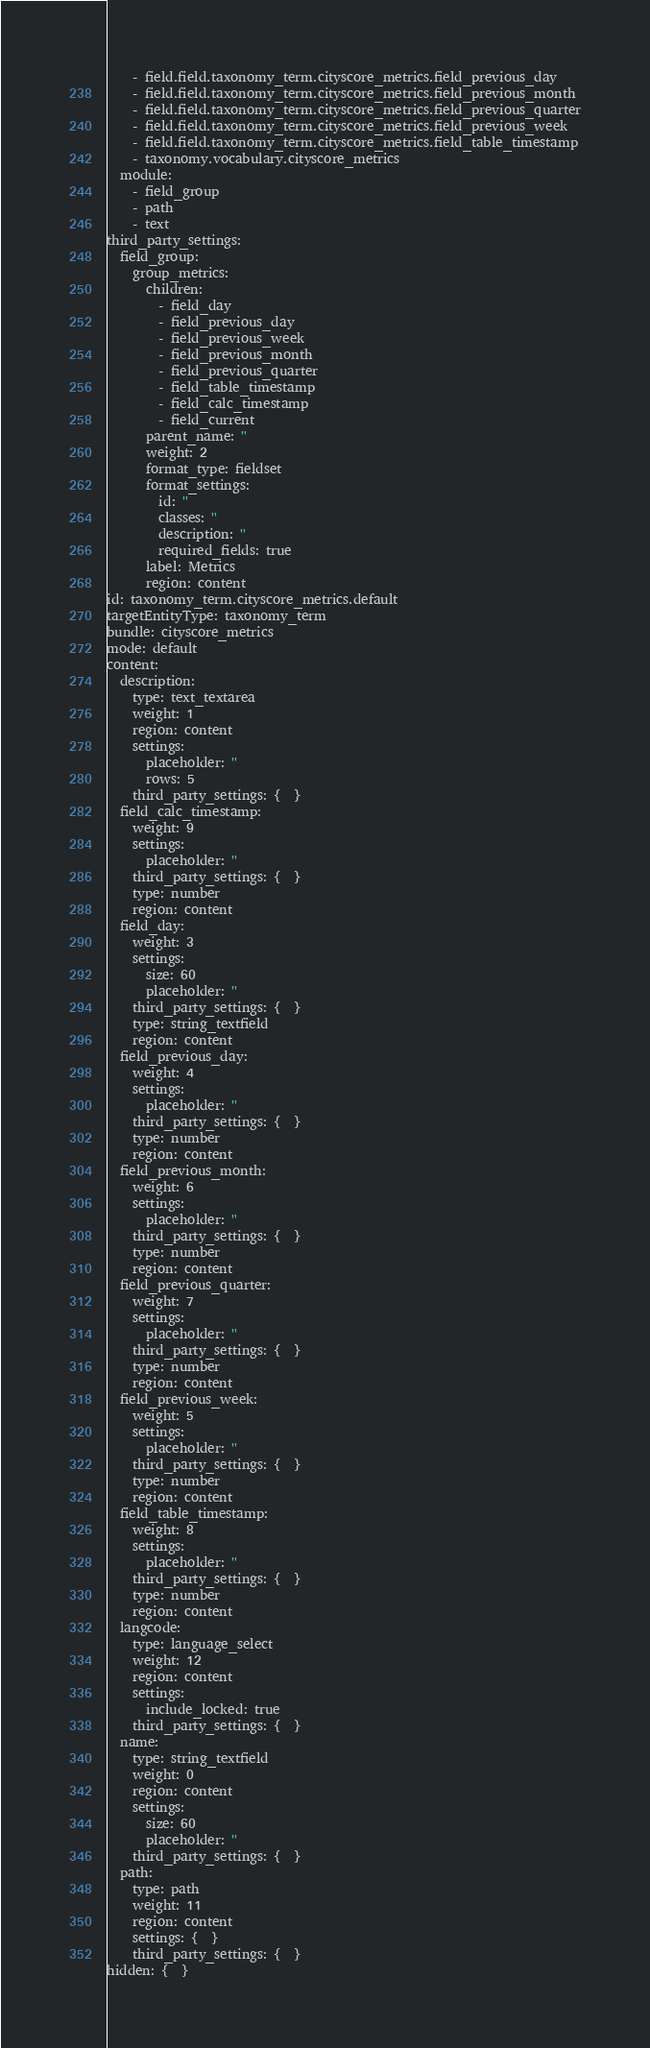Convert code to text. <code><loc_0><loc_0><loc_500><loc_500><_YAML_>    - field.field.taxonomy_term.cityscore_metrics.field_previous_day
    - field.field.taxonomy_term.cityscore_metrics.field_previous_month
    - field.field.taxonomy_term.cityscore_metrics.field_previous_quarter
    - field.field.taxonomy_term.cityscore_metrics.field_previous_week
    - field.field.taxonomy_term.cityscore_metrics.field_table_timestamp
    - taxonomy.vocabulary.cityscore_metrics
  module:
    - field_group
    - path
    - text
third_party_settings:
  field_group:
    group_metrics:
      children:
        - field_day
        - field_previous_day
        - field_previous_week
        - field_previous_month
        - field_previous_quarter
        - field_table_timestamp
        - field_calc_timestamp
        - field_current
      parent_name: ''
      weight: 2
      format_type: fieldset
      format_settings:
        id: ''
        classes: ''
        description: ''
        required_fields: true
      label: Metrics
      region: content
id: taxonomy_term.cityscore_metrics.default
targetEntityType: taxonomy_term
bundle: cityscore_metrics
mode: default
content:
  description:
    type: text_textarea
    weight: 1
    region: content
    settings:
      placeholder: ''
      rows: 5
    third_party_settings: {  }
  field_calc_timestamp:
    weight: 9
    settings:
      placeholder: ''
    third_party_settings: {  }
    type: number
    region: content
  field_day:
    weight: 3
    settings:
      size: 60
      placeholder: ''
    third_party_settings: {  }
    type: string_textfield
    region: content
  field_previous_day:
    weight: 4
    settings:
      placeholder: ''
    third_party_settings: {  }
    type: number
    region: content
  field_previous_month:
    weight: 6
    settings:
      placeholder: ''
    third_party_settings: {  }
    type: number
    region: content
  field_previous_quarter:
    weight: 7
    settings:
      placeholder: ''
    third_party_settings: {  }
    type: number
    region: content
  field_previous_week:
    weight: 5
    settings:
      placeholder: ''
    third_party_settings: {  }
    type: number
    region: content
  field_table_timestamp:
    weight: 8
    settings:
      placeholder: ''
    third_party_settings: {  }
    type: number
    region: content
  langcode:
    type: language_select
    weight: 12
    region: content
    settings:
      include_locked: true
    third_party_settings: {  }
  name:
    type: string_textfield
    weight: 0
    region: content
    settings:
      size: 60
      placeholder: ''
    third_party_settings: {  }
  path:
    type: path
    weight: 11
    region: content
    settings: {  }
    third_party_settings: {  }
hidden: {  }
</code> 